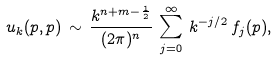Convert formula to latex. <formula><loc_0><loc_0><loc_500><loc_500>u _ { k } ( p , p ) \, \sim \, \frac { k ^ { n + m - \frac { 1 } { 2 } } } { ( 2 \pi ) ^ { n } } \, \sum _ { j = 0 } ^ { \infty } \, k ^ { - j / 2 } \, f _ { j } ( p ) ,</formula> 